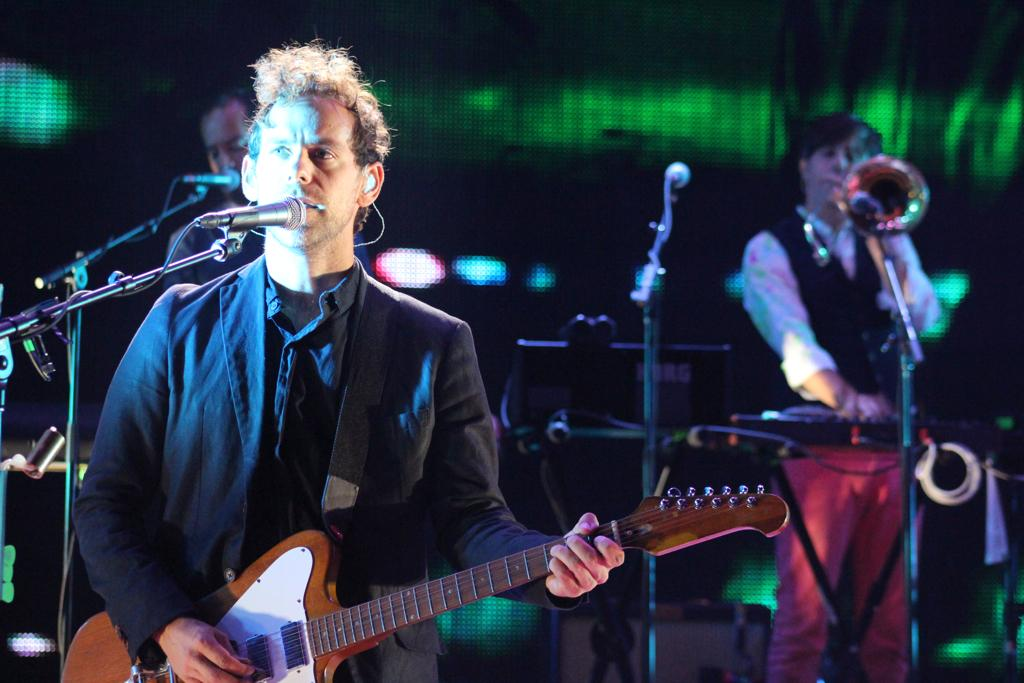What are the people in the image doing? The people in the image are singing. Can you describe any specific actions or objects related to the singing? At least one person is holding a microphone. Is there a person leading the group in the image? Yes, there is a person standing in front of the group. What instrument is the person in front holding? The person in front is holding a guitar. What type of letters are being discussed by the group in the image? There is no mention of letters or a discussion in the image; the people are singing. 